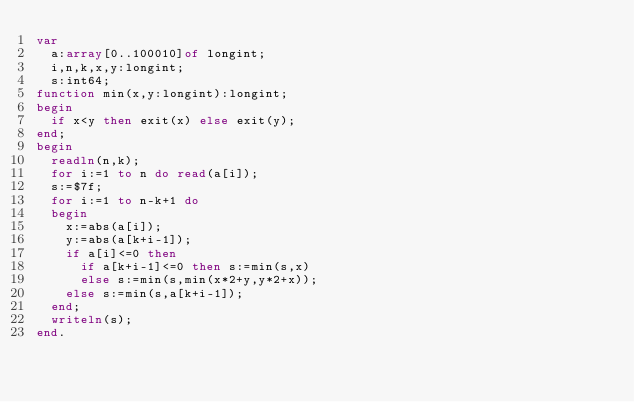Convert code to text. <code><loc_0><loc_0><loc_500><loc_500><_Pascal_>var
	a:array[0..100010]of longint;
	i,n,k,x,y:longint;
	s:int64;
function min(x,y:longint):longint;
begin
	if x<y then exit(x) else exit(y);
end;
begin
	readln(n,k);
	for i:=1 to n do read(a[i]);
	s:=$7f;
	for i:=1 to n-k+1 do
	begin
		x:=abs(a[i]);
		y:=abs(a[k+i-1]);
		if a[i]<=0 then
			if a[k+i-1]<=0 then s:=min(s,x)
			else s:=min(s,min(x*2+y,y*2+x));
		else s:=min(s,a[k+i-1]);
	end;
	writeln(s);
end.</code> 